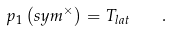Convert formula to latex. <formula><loc_0><loc_0><loc_500><loc_500>p _ { 1 } \left ( s y m ^ { \times } \right ) = T _ { l a t } \quad .</formula> 